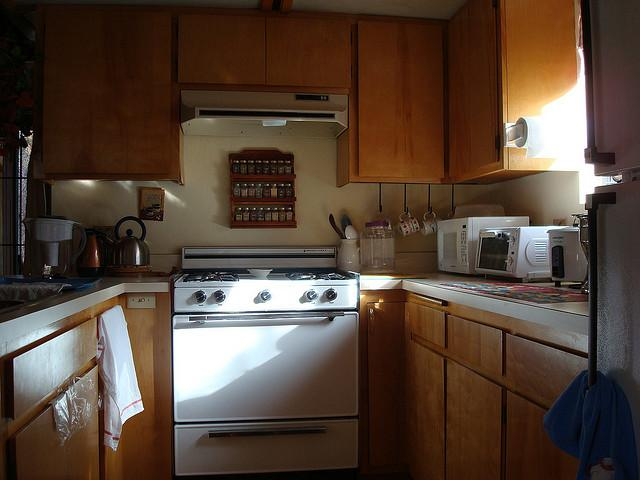What would someone use the objects above the stove for? Please explain your reasoning. seasoning. The seasoning is used. 